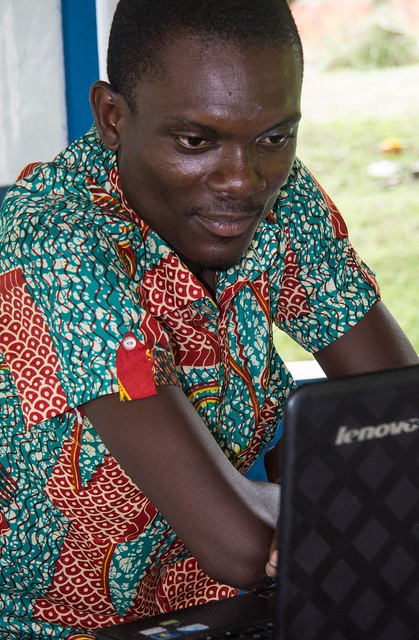Describe the objects in this image and their specific colors. I can see people in lightgray, maroon, black, teal, and gray tones and laptop in lightgray, black, and gray tones in this image. 